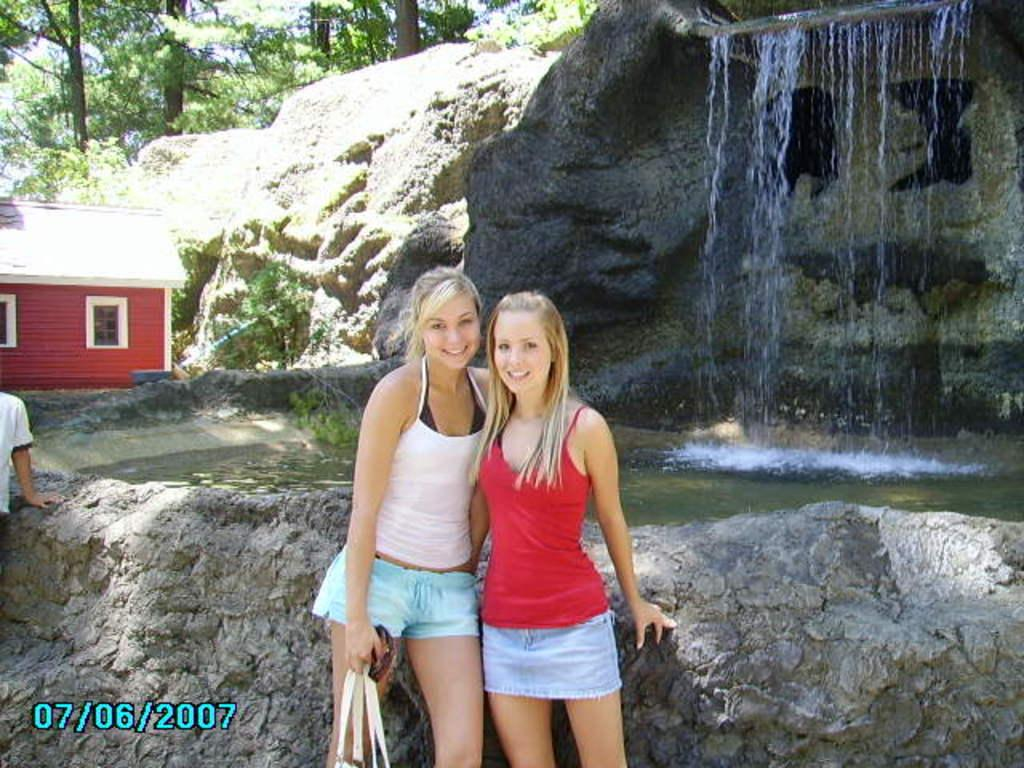<image>
Describe the image concisely. A few older girls are posing for the camera in front of a waterfall, with the photo being dated 07/06/2007. 